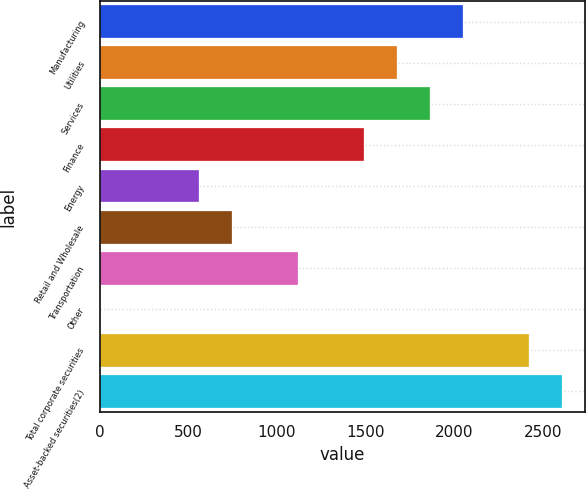Convert chart to OTSL. <chart><loc_0><loc_0><loc_500><loc_500><bar_chart><fcel>Manufacturing<fcel>Utilities<fcel>Services<fcel>Finance<fcel>Energy<fcel>Retail and Wholesale<fcel>Transportation<fcel>Other<fcel>Total corporate securities<fcel>Asset-backed securities(2)<nl><fcel>2050.3<fcel>1677.64<fcel>1863.97<fcel>1491.31<fcel>559.66<fcel>745.99<fcel>1118.65<fcel>0.67<fcel>2422.96<fcel>2609.29<nl></chart> 